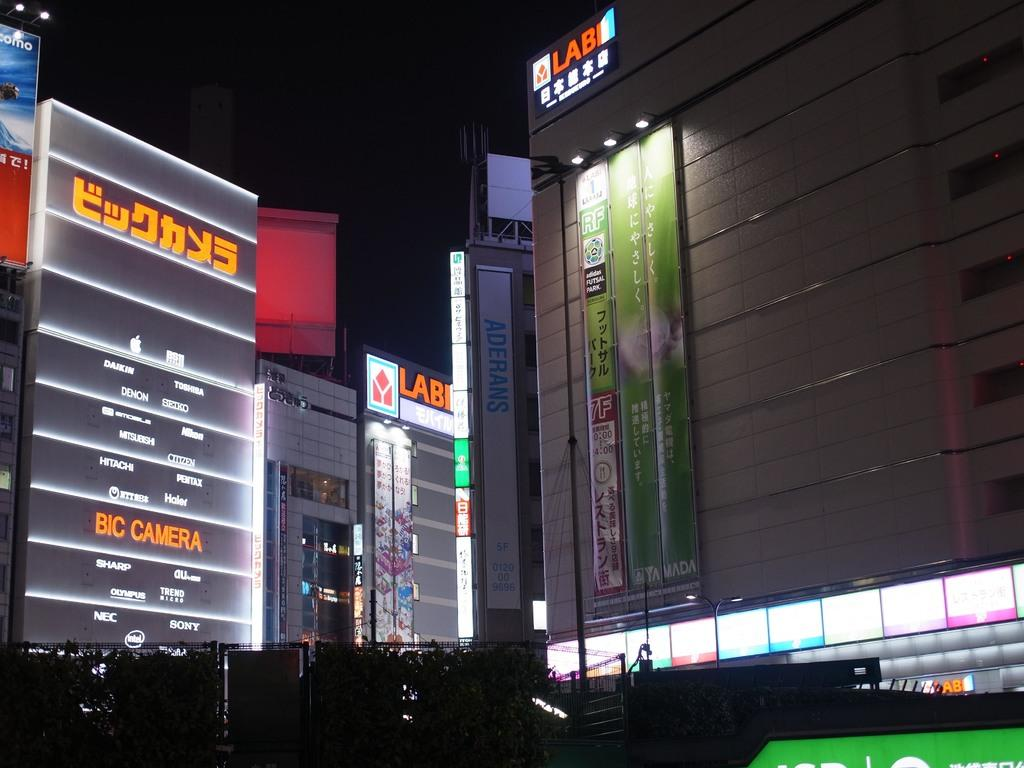<image>
Relay a brief, clear account of the picture shown. Several major electronic companies are advertised on the neon signs such as Sony, Sharp and Toshiba. 